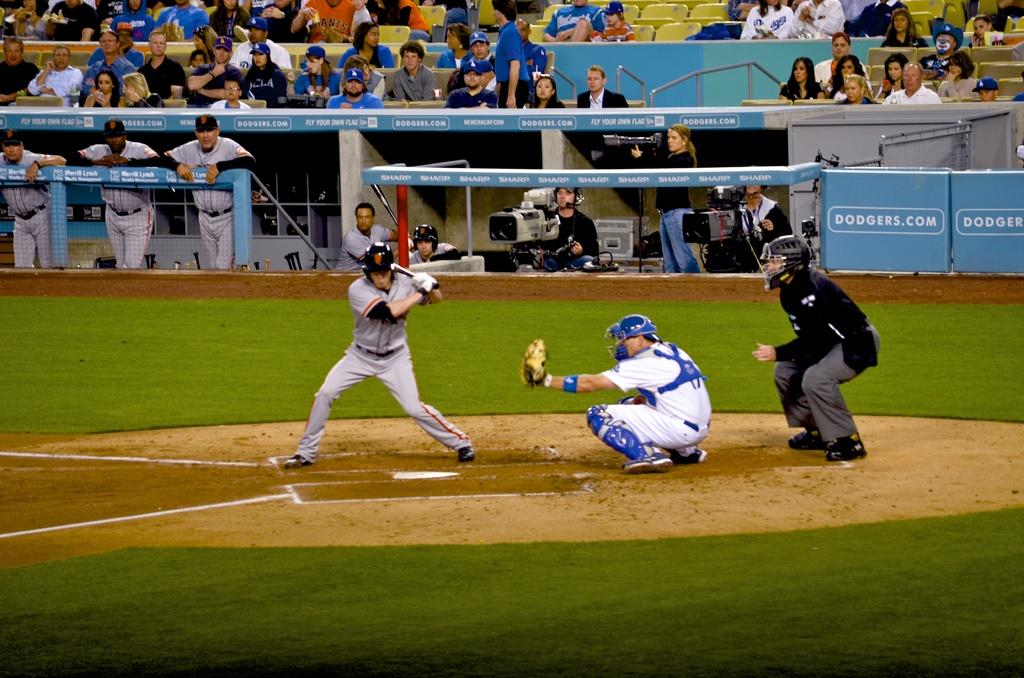<image>
Offer a succinct explanation of the picture presented. a batter with the SF logo on his helmet 